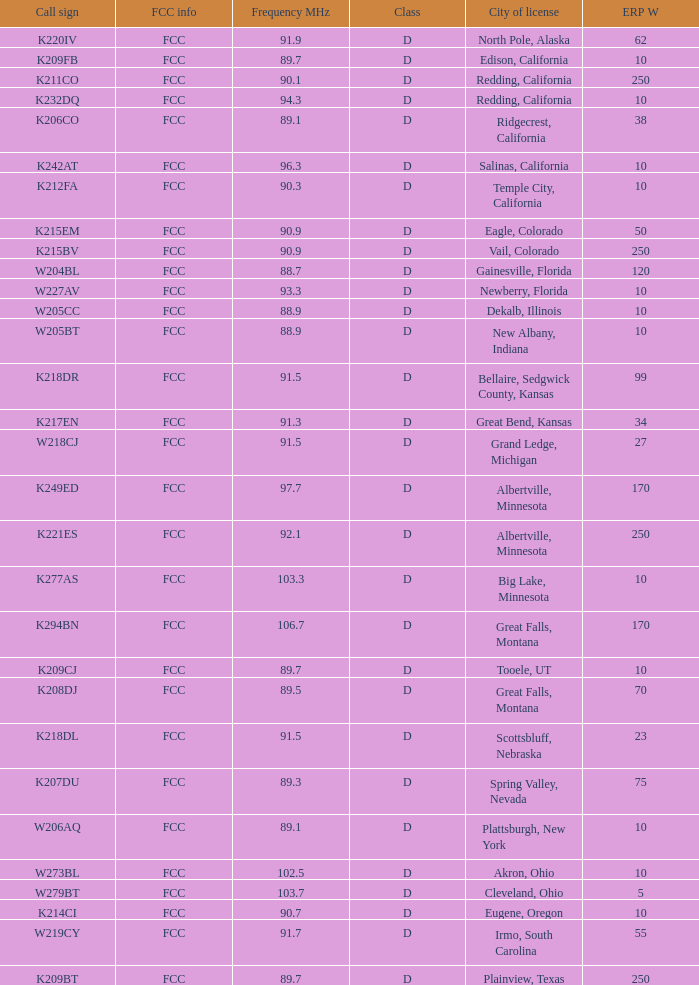What is the highest ERP W of an 89.1 frequency translator? 38.0. 